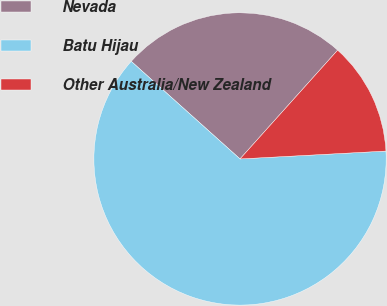Convert chart to OTSL. <chart><loc_0><loc_0><loc_500><loc_500><pie_chart><fcel>Nevada<fcel>Batu Hijau<fcel>Other Australia/New Zealand<nl><fcel>25.0%<fcel>62.5%<fcel>12.5%<nl></chart> 